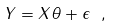Convert formula to latex. <formula><loc_0><loc_0><loc_500><loc_500>Y = { X } \theta + \epsilon \ ,</formula> 